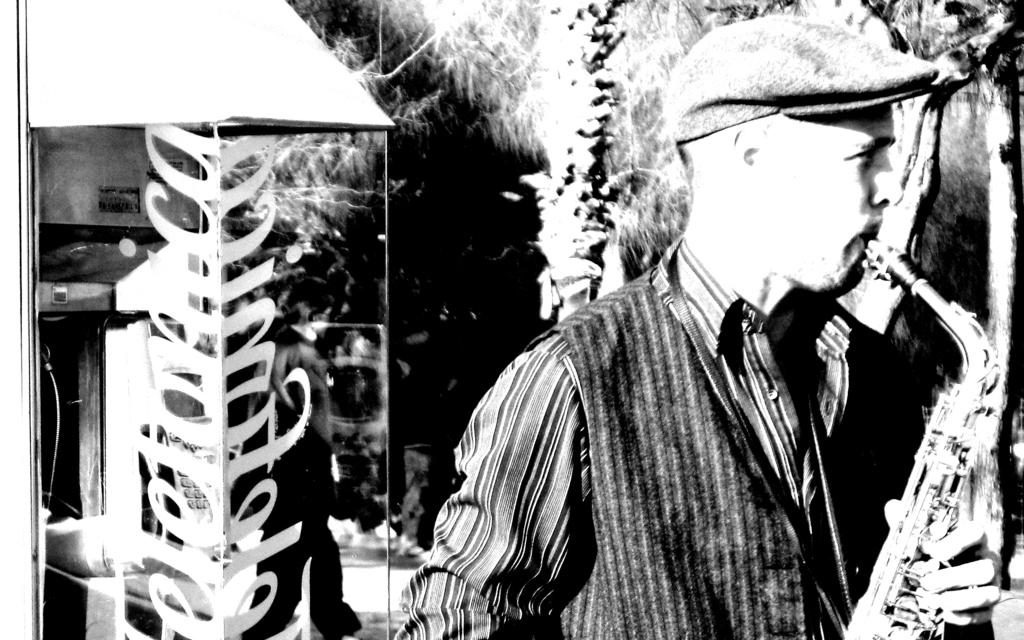What is the color scheme of the image? The image is black and white. Who is present in the image? There is a man in the image. What is the man holding in the image? The man is holding a trumpet. What type of natural environment can be seen in the image? There are trees visible in the image. What type of news can be seen on the light in the image? There is no light or news present in the image; it is a black and white image of a man holding a trumpet with trees in the background. 